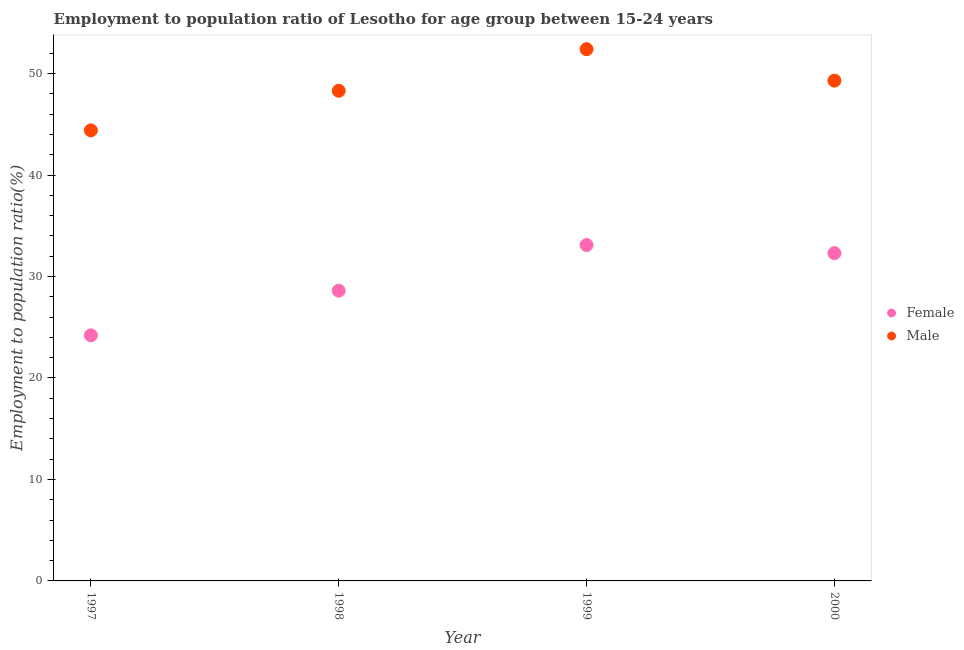How many different coloured dotlines are there?
Your answer should be very brief. 2. What is the employment to population ratio(male) in 1997?
Make the answer very short. 44.4. Across all years, what is the maximum employment to population ratio(female)?
Provide a short and direct response. 33.1. Across all years, what is the minimum employment to population ratio(male)?
Provide a short and direct response. 44.4. In which year was the employment to population ratio(female) maximum?
Offer a very short reply. 1999. In which year was the employment to population ratio(male) minimum?
Give a very brief answer. 1997. What is the total employment to population ratio(female) in the graph?
Provide a short and direct response. 118.2. What is the difference between the employment to population ratio(male) in 1997 and that in 1998?
Provide a succinct answer. -3.9. What is the difference between the employment to population ratio(female) in 2000 and the employment to population ratio(male) in 1998?
Provide a short and direct response. -16. What is the average employment to population ratio(female) per year?
Provide a succinct answer. 29.55. In the year 1997, what is the difference between the employment to population ratio(female) and employment to population ratio(male)?
Your response must be concise. -20.2. What is the ratio of the employment to population ratio(female) in 1997 to that in 1998?
Offer a very short reply. 0.85. Is the employment to population ratio(male) in 1997 less than that in 1999?
Offer a terse response. Yes. Is the difference between the employment to population ratio(male) in 1999 and 2000 greater than the difference between the employment to population ratio(female) in 1999 and 2000?
Ensure brevity in your answer.  Yes. What is the difference between the highest and the second highest employment to population ratio(female)?
Give a very brief answer. 0.8. What is the difference between the highest and the lowest employment to population ratio(male)?
Offer a very short reply. 8. In how many years, is the employment to population ratio(male) greater than the average employment to population ratio(male) taken over all years?
Provide a short and direct response. 2. Is the employment to population ratio(male) strictly less than the employment to population ratio(female) over the years?
Offer a terse response. No. How many years are there in the graph?
Offer a very short reply. 4. What is the difference between two consecutive major ticks on the Y-axis?
Your response must be concise. 10. Are the values on the major ticks of Y-axis written in scientific E-notation?
Ensure brevity in your answer.  No. Does the graph contain any zero values?
Your answer should be very brief. No. How many legend labels are there?
Your answer should be compact. 2. How are the legend labels stacked?
Keep it short and to the point. Vertical. What is the title of the graph?
Make the answer very short. Employment to population ratio of Lesotho for age group between 15-24 years. Does "Chemicals" appear as one of the legend labels in the graph?
Provide a succinct answer. No. What is the Employment to population ratio(%) in Female in 1997?
Your answer should be very brief. 24.2. What is the Employment to population ratio(%) of Male in 1997?
Your answer should be very brief. 44.4. What is the Employment to population ratio(%) in Female in 1998?
Your answer should be very brief. 28.6. What is the Employment to population ratio(%) of Male in 1998?
Keep it short and to the point. 48.3. What is the Employment to population ratio(%) in Female in 1999?
Give a very brief answer. 33.1. What is the Employment to population ratio(%) of Male in 1999?
Keep it short and to the point. 52.4. What is the Employment to population ratio(%) of Female in 2000?
Your answer should be compact. 32.3. What is the Employment to population ratio(%) in Male in 2000?
Offer a very short reply. 49.3. Across all years, what is the maximum Employment to population ratio(%) in Female?
Make the answer very short. 33.1. Across all years, what is the maximum Employment to population ratio(%) in Male?
Provide a short and direct response. 52.4. Across all years, what is the minimum Employment to population ratio(%) of Female?
Provide a succinct answer. 24.2. Across all years, what is the minimum Employment to population ratio(%) of Male?
Your response must be concise. 44.4. What is the total Employment to population ratio(%) in Female in the graph?
Your answer should be compact. 118.2. What is the total Employment to population ratio(%) in Male in the graph?
Your answer should be compact. 194.4. What is the difference between the Employment to population ratio(%) in Female in 1998 and that in 1999?
Your response must be concise. -4.5. What is the difference between the Employment to population ratio(%) of Female in 1998 and that in 2000?
Provide a short and direct response. -3.7. What is the difference between the Employment to population ratio(%) in Male in 1998 and that in 2000?
Your answer should be compact. -1. What is the difference between the Employment to population ratio(%) of Female in 1999 and that in 2000?
Offer a very short reply. 0.8. What is the difference between the Employment to population ratio(%) in Female in 1997 and the Employment to population ratio(%) in Male in 1998?
Provide a succinct answer. -24.1. What is the difference between the Employment to population ratio(%) in Female in 1997 and the Employment to population ratio(%) in Male in 1999?
Your answer should be very brief. -28.2. What is the difference between the Employment to population ratio(%) of Female in 1997 and the Employment to population ratio(%) of Male in 2000?
Offer a terse response. -25.1. What is the difference between the Employment to population ratio(%) in Female in 1998 and the Employment to population ratio(%) in Male in 1999?
Provide a short and direct response. -23.8. What is the difference between the Employment to population ratio(%) of Female in 1998 and the Employment to population ratio(%) of Male in 2000?
Offer a very short reply. -20.7. What is the difference between the Employment to population ratio(%) of Female in 1999 and the Employment to population ratio(%) of Male in 2000?
Make the answer very short. -16.2. What is the average Employment to population ratio(%) in Female per year?
Offer a very short reply. 29.55. What is the average Employment to population ratio(%) in Male per year?
Ensure brevity in your answer.  48.6. In the year 1997, what is the difference between the Employment to population ratio(%) in Female and Employment to population ratio(%) in Male?
Make the answer very short. -20.2. In the year 1998, what is the difference between the Employment to population ratio(%) in Female and Employment to population ratio(%) in Male?
Offer a very short reply. -19.7. In the year 1999, what is the difference between the Employment to population ratio(%) of Female and Employment to population ratio(%) of Male?
Your answer should be compact. -19.3. In the year 2000, what is the difference between the Employment to population ratio(%) in Female and Employment to population ratio(%) in Male?
Keep it short and to the point. -17. What is the ratio of the Employment to population ratio(%) of Female in 1997 to that in 1998?
Provide a short and direct response. 0.85. What is the ratio of the Employment to population ratio(%) in Male in 1997 to that in 1998?
Your answer should be very brief. 0.92. What is the ratio of the Employment to population ratio(%) in Female in 1997 to that in 1999?
Give a very brief answer. 0.73. What is the ratio of the Employment to population ratio(%) of Male in 1997 to that in 1999?
Make the answer very short. 0.85. What is the ratio of the Employment to population ratio(%) of Female in 1997 to that in 2000?
Your answer should be very brief. 0.75. What is the ratio of the Employment to population ratio(%) of Male in 1997 to that in 2000?
Provide a succinct answer. 0.9. What is the ratio of the Employment to population ratio(%) of Female in 1998 to that in 1999?
Offer a terse response. 0.86. What is the ratio of the Employment to population ratio(%) in Male in 1998 to that in 1999?
Your response must be concise. 0.92. What is the ratio of the Employment to population ratio(%) of Female in 1998 to that in 2000?
Provide a succinct answer. 0.89. What is the ratio of the Employment to population ratio(%) in Male in 1998 to that in 2000?
Give a very brief answer. 0.98. What is the ratio of the Employment to population ratio(%) of Female in 1999 to that in 2000?
Your answer should be compact. 1.02. What is the ratio of the Employment to population ratio(%) of Male in 1999 to that in 2000?
Ensure brevity in your answer.  1.06. What is the difference between the highest and the second highest Employment to population ratio(%) in Female?
Offer a very short reply. 0.8. What is the difference between the highest and the lowest Employment to population ratio(%) of Female?
Ensure brevity in your answer.  8.9. What is the difference between the highest and the lowest Employment to population ratio(%) in Male?
Provide a succinct answer. 8. 